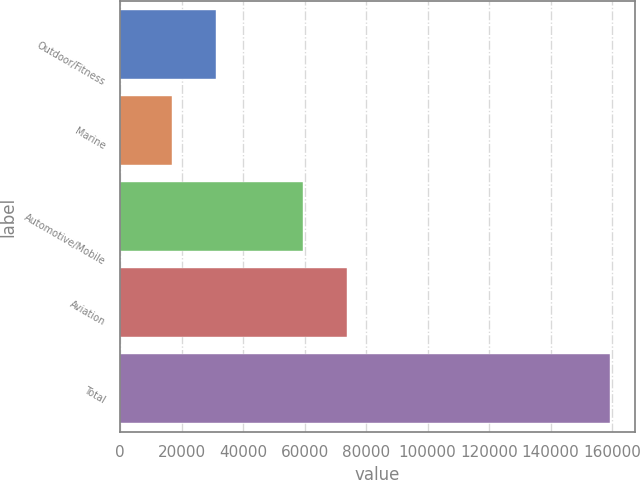Convert chart to OTSL. <chart><loc_0><loc_0><loc_500><loc_500><bar_chart><fcel>Outdoor/Fitness<fcel>Marine<fcel>Automotive/Mobile<fcel>Aviation<fcel>Total<nl><fcel>31131.7<fcel>16879<fcel>59390<fcel>73642.7<fcel>159406<nl></chart> 